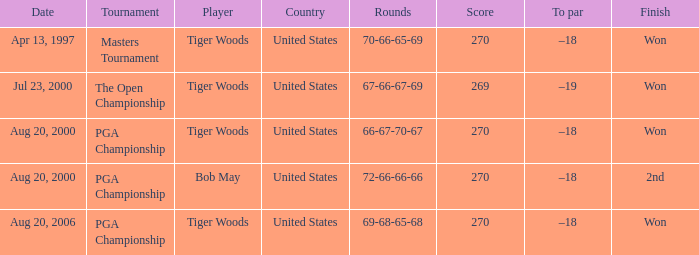What competitors concluded in 2nd position? Bob May. 